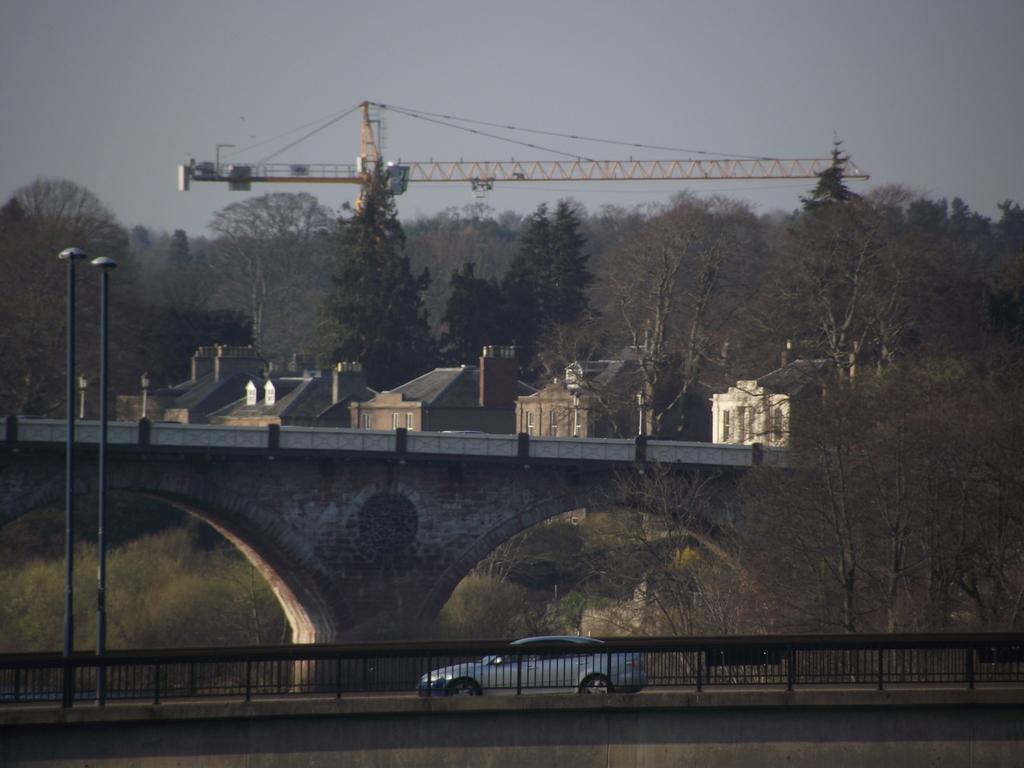Could you give a brief overview of what you see in this image? There is a fence and a car is present at the bottom of this image. We can see a bridge, trees, houses and a crane are in the background and the sky is at the top of this image. We can see poles on the left side of this image. 